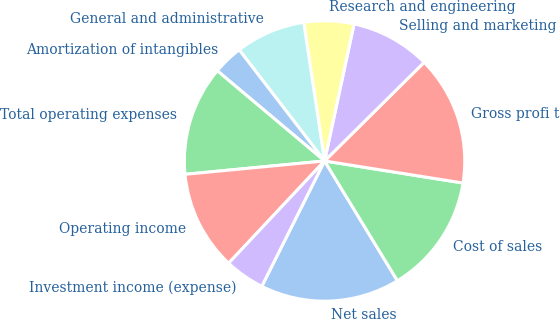<chart> <loc_0><loc_0><loc_500><loc_500><pie_chart><fcel>Net sales<fcel>Cost of sales<fcel>Gross profi t<fcel>Selling and marketing<fcel>Research and engineering<fcel>General and administrative<fcel>Amortization of intangibles<fcel>Total operating expenses<fcel>Operating income<fcel>Investment income (expense)<nl><fcel>16.09%<fcel>13.79%<fcel>14.94%<fcel>9.2%<fcel>5.75%<fcel>8.05%<fcel>3.45%<fcel>12.64%<fcel>11.49%<fcel>4.6%<nl></chart> 